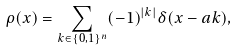<formula> <loc_0><loc_0><loc_500><loc_500>\rho ( x ) = \sum _ { k \in \{ 0 , 1 \} ^ { n } } ( - 1 ) ^ { | k | } \delta ( x - a k ) ,</formula> 